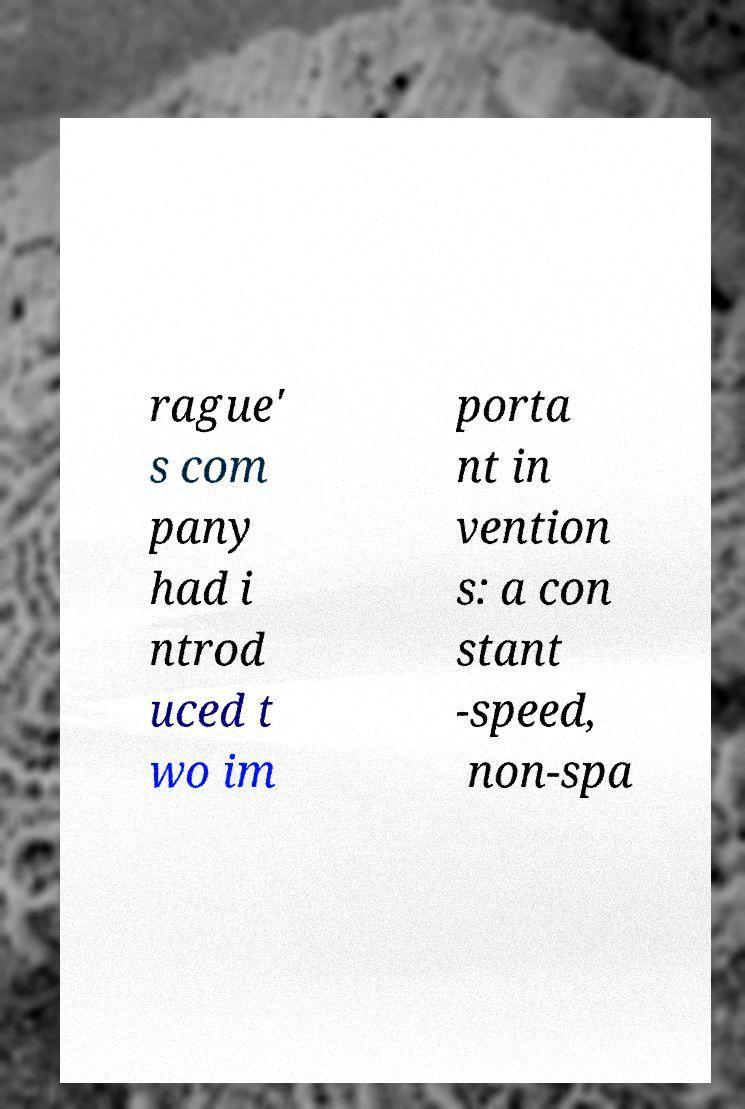Can you accurately transcribe the text from the provided image for me? rague' s com pany had i ntrod uced t wo im porta nt in vention s: a con stant -speed, non-spa 